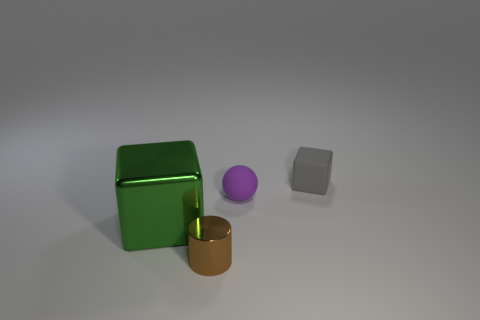Add 3 rubber objects. How many objects exist? 7 Subtract all cylinders. How many objects are left? 3 Add 3 tiny cubes. How many tiny cubes are left? 4 Add 4 purple balls. How many purple balls exist? 5 Subtract 0 brown spheres. How many objects are left? 4 Subtract all large blue metal things. Subtract all small balls. How many objects are left? 3 